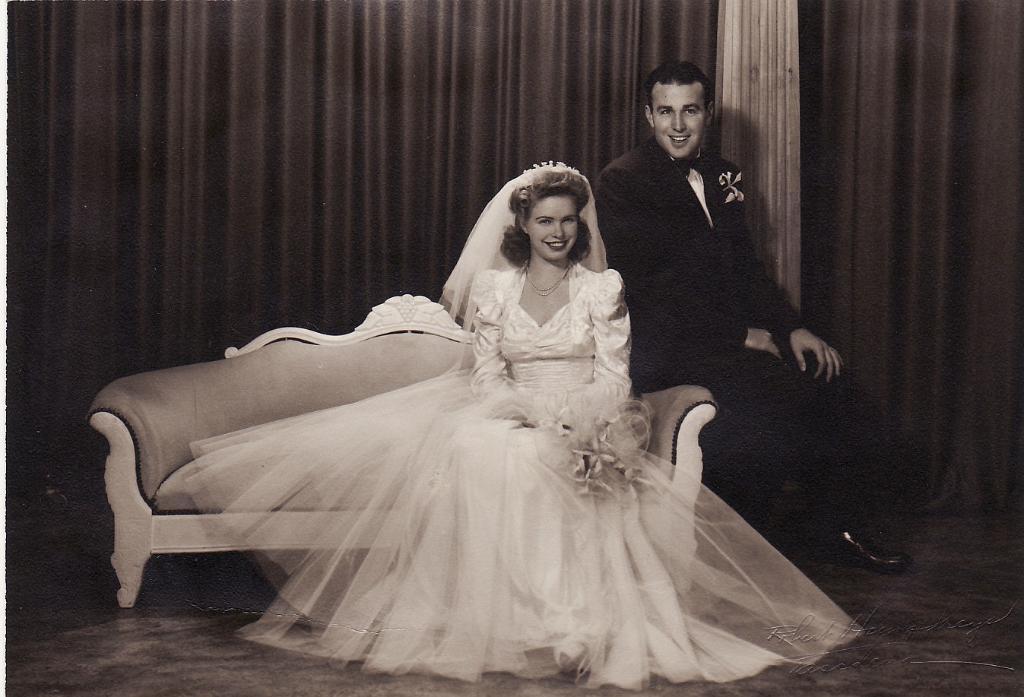In one or two sentences, can you explain what this image depicts? As we can see in the image there are curtains and two people sitting on sofa. The woman is wearing white color dress and the man is wearing black color jacket. 